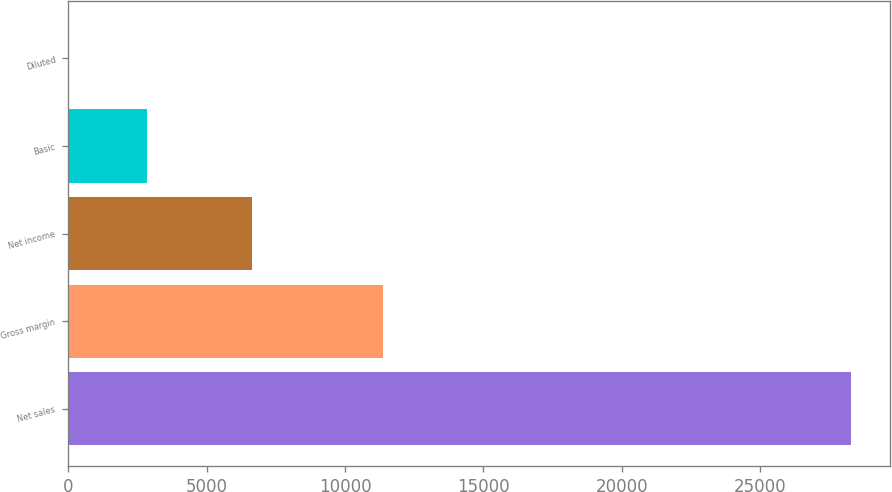Convert chart. <chart><loc_0><loc_0><loc_500><loc_500><bar_chart><fcel>Net sales<fcel>Gross margin<fcel>Net income<fcel>Basic<fcel>Diluted<nl><fcel>28270<fcel>11380<fcel>6623<fcel>2833.35<fcel>7.05<nl></chart> 